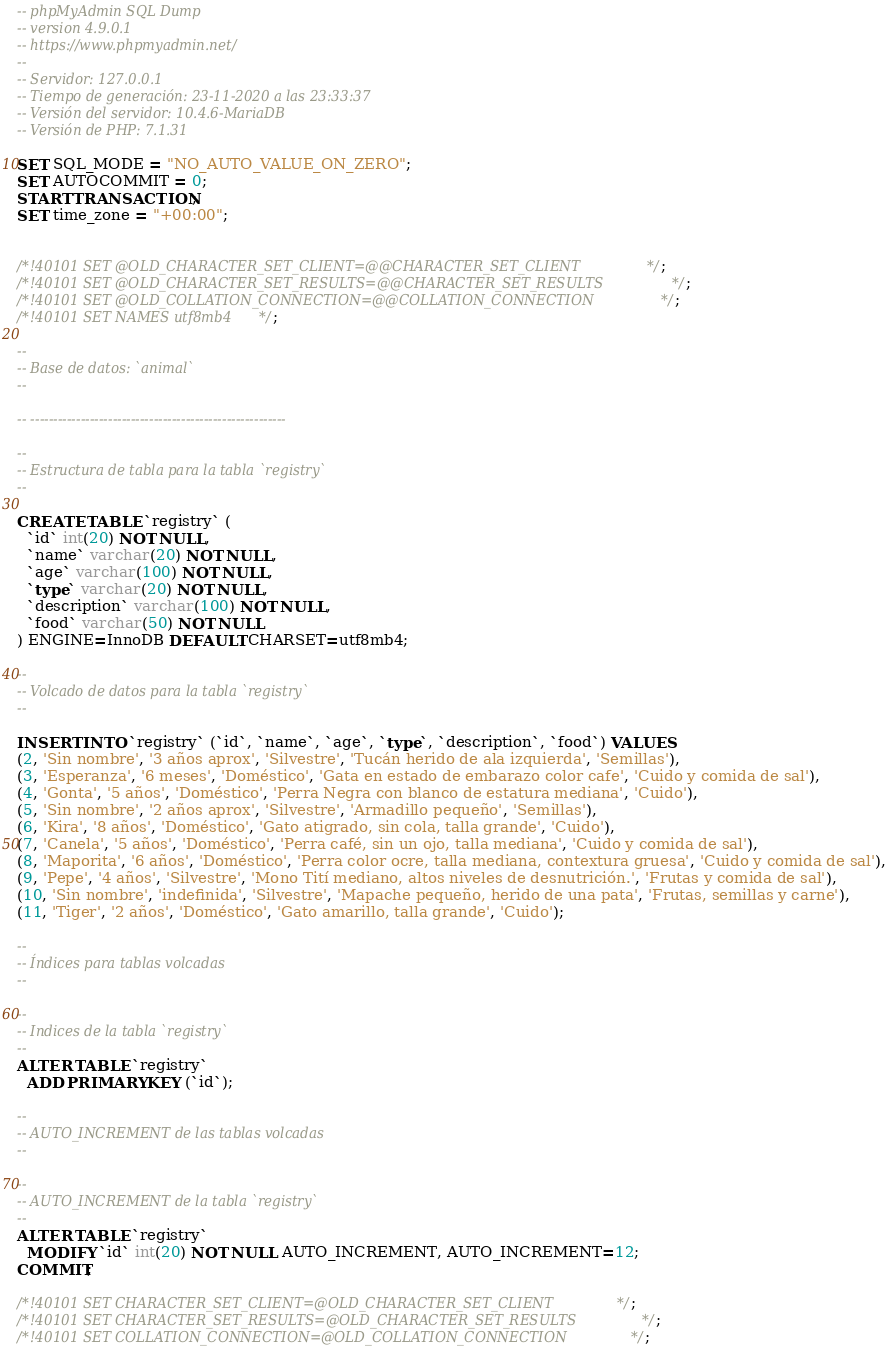<code> <loc_0><loc_0><loc_500><loc_500><_SQL_>-- phpMyAdmin SQL Dump
-- version 4.9.0.1
-- https://www.phpmyadmin.net/
--
-- Servidor: 127.0.0.1
-- Tiempo de generación: 23-11-2020 a las 23:33:37
-- Versión del servidor: 10.4.6-MariaDB
-- Versión de PHP: 7.1.31

SET SQL_MODE = "NO_AUTO_VALUE_ON_ZERO";
SET AUTOCOMMIT = 0;
START TRANSACTION;
SET time_zone = "+00:00";


/*!40101 SET @OLD_CHARACTER_SET_CLIENT=@@CHARACTER_SET_CLIENT */;
/*!40101 SET @OLD_CHARACTER_SET_RESULTS=@@CHARACTER_SET_RESULTS */;
/*!40101 SET @OLD_COLLATION_CONNECTION=@@COLLATION_CONNECTION */;
/*!40101 SET NAMES utf8mb4 */;

--
-- Base de datos: `animal`
--

-- --------------------------------------------------------

--
-- Estructura de tabla para la tabla `registry`
--

CREATE TABLE `registry` (
  `id` int(20) NOT NULL,
  `name` varchar(20) NOT NULL,
  `age` varchar(100) NOT NULL,
  `type` varchar(20) NOT NULL,
  `description` varchar(100) NOT NULL,
  `food` varchar(50) NOT NULL
) ENGINE=InnoDB DEFAULT CHARSET=utf8mb4;

--
-- Volcado de datos para la tabla `registry`
--

INSERT INTO `registry` (`id`, `name`, `age`, `type`, `description`, `food`) VALUES
(2, 'Sin nombre', '3 años aprox', 'Silvestre', 'Tucán herido de ala izquierda', 'Semillas'),
(3, 'Esperanza', '6 meses', 'Doméstico', 'Gata en estado de embarazo color cafe', 'Cuido y comida de sal'),
(4, 'Gonta', '5 años', 'Doméstico', 'Perra Negra con blanco de estatura mediana', 'Cuido'),
(5, 'Sin nombre', '2 años aprox', 'Silvestre', 'Armadillo pequeño', 'Semillas'),
(6, 'Kira', '8 años', 'Doméstico', 'Gato atigrado, sin cola, talla grande', 'Cuido'),
(7, 'Canela', '5 años', 'Doméstico', 'Perra café, sin un ojo, talla mediana', 'Cuido y comida de sal'),
(8, 'Maporita', '6 años', 'Doméstico', 'Perra color ocre, talla mediana, contextura gruesa', 'Cuido y comida de sal'),
(9, 'Pepe', '4 años', 'Silvestre', 'Mono Tití mediano, altos niveles de desnutrición.', 'Frutas y comida de sal'),
(10, 'Sin nombre', 'indefinida', 'Silvestre', 'Mapache pequeño, herido de una pata', 'Frutas, semillas y carne'),
(11, 'Tiger', '2 años', 'Doméstico', 'Gato amarillo, talla grande', 'Cuido');

--
-- Índices para tablas volcadas
--

--
-- Indices de la tabla `registry`
--
ALTER TABLE `registry`
  ADD PRIMARY KEY (`id`);

--
-- AUTO_INCREMENT de las tablas volcadas
--

--
-- AUTO_INCREMENT de la tabla `registry`
--
ALTER TABLE `registry`
  MODIFY `id` int(20) NOT NULL AUTO_INCREMENT, AUTO_INCREMENT=12;
COMMIT;

/*!40101 SET CHARACTER_SET_CLIENT=@OLD_CHARACTER_SET_CLIENT */;
/*!40101 SET CHARACTER_SET_RESULTS=@OLD_CHARACTER_SET_RESULTS */;
/*!40101 SET COLLATION_CONNECTION=@OLD_COLLATION_CONNECTION */;
</code> 